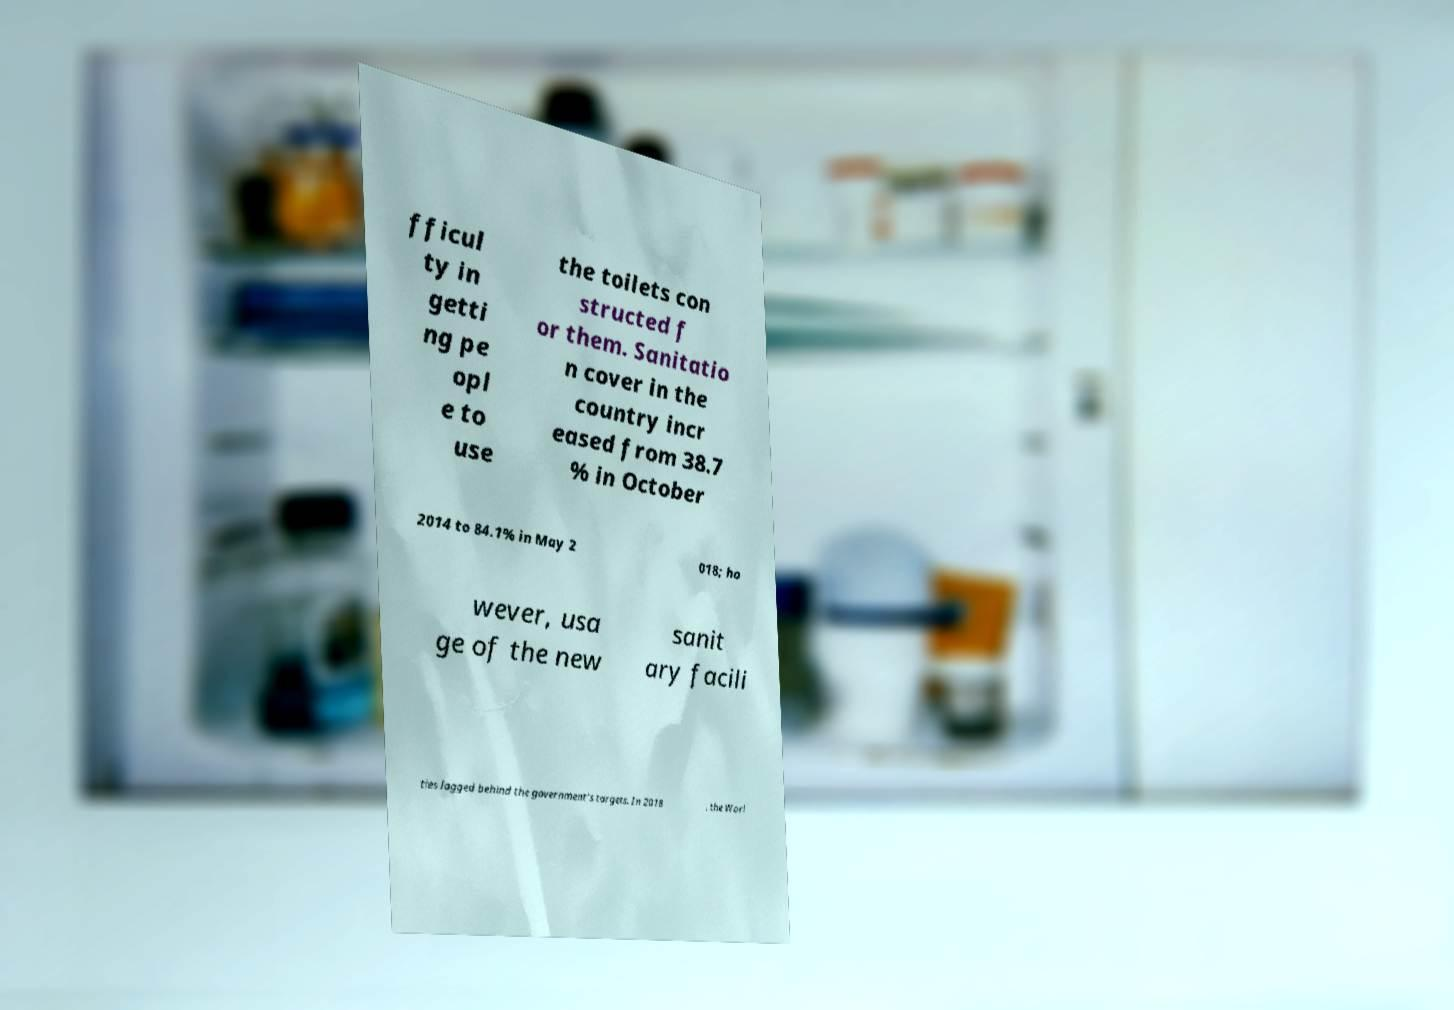Can you accurately transcribe the text from the provided image for me? fficul ty in getti ng pe opl e to use the toilets con structed f or them. Sanitatio n cover in the country incr eased from 38.7 % in October 2014 to 84.1% in May 2 018; ho wever, usa ge of the new sanit ary facili ties lagged behind the government's targets. In 2018 , the Worl 